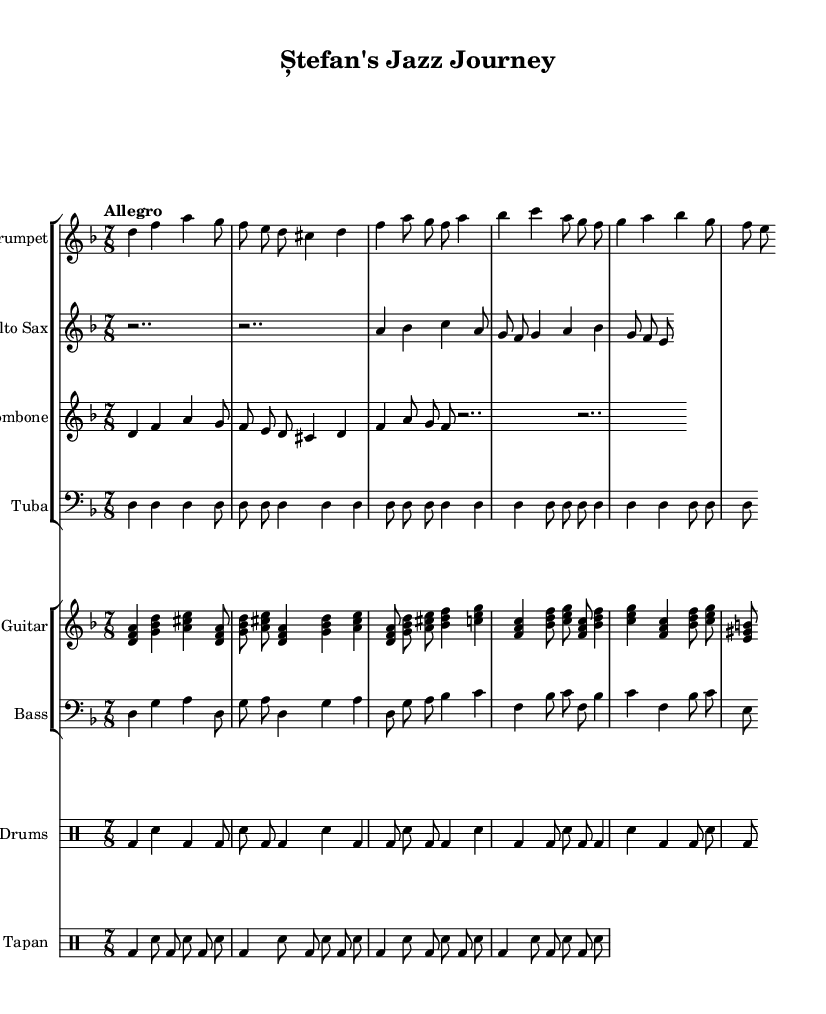What is the key signature of this music? The key signature is indicated by the key at the beginning of the score, which shows D minor with one flat (B flat).
Answer: D minor What is the time signature of the piece? The time signature is the number of beats in a measure, which is also indicated at the beginning of the score. Here, it shows 7/8, meaning there are seven eighth notes in each measure.
Answer: 7/8 What is the tempo marking for this composition? The tempo marking is shown at the beginning of the score, indicating the speed of the piece. It states "Allegro," which means to play at a fast, lively tempo.
Answer: Allegro Which instruments are featured in this composition? The instruments are listed at the top of each staff, revealing the variety of instruments involved. The instruments here include Trumpet, Alto Sax, Trombone, Tuba, Guitar, Bass, Drums, and Tapan.
Answer: Trumpet, Alto Sax, Trombone, Tuba, Guitar, Bass, Drums, Tapan What is the rhythmic pattern used by the drums? By examining the drum part, we can see that it consists of a repetitive pattern, with bass drums and snare hits. The score indicates a consistent articulation throughout all measures.
Answer: Repetitive bass and snare pattern How does the fusion of jazz elements manifest in the instrumentation? The use of brass instruments combined with guitar, bass, and drums represents a typical jazz ensemble. The improvisational nature of jazz is suggested by the variable melodic lines and syncopated rhythms seen throughout the score.
Answer: Brass and guitar ensemble with improvisation What medieval tale does this piece reflect? The title "Ștefan's Jazz Journey" suggests a connection to historic tales about Ștefan the Great of Moldova, known for resisting invaders and strong leadership. The music may encapsulate the essence of his journey through lively and dramatic motifs.
Answer: Ștefan the Great 